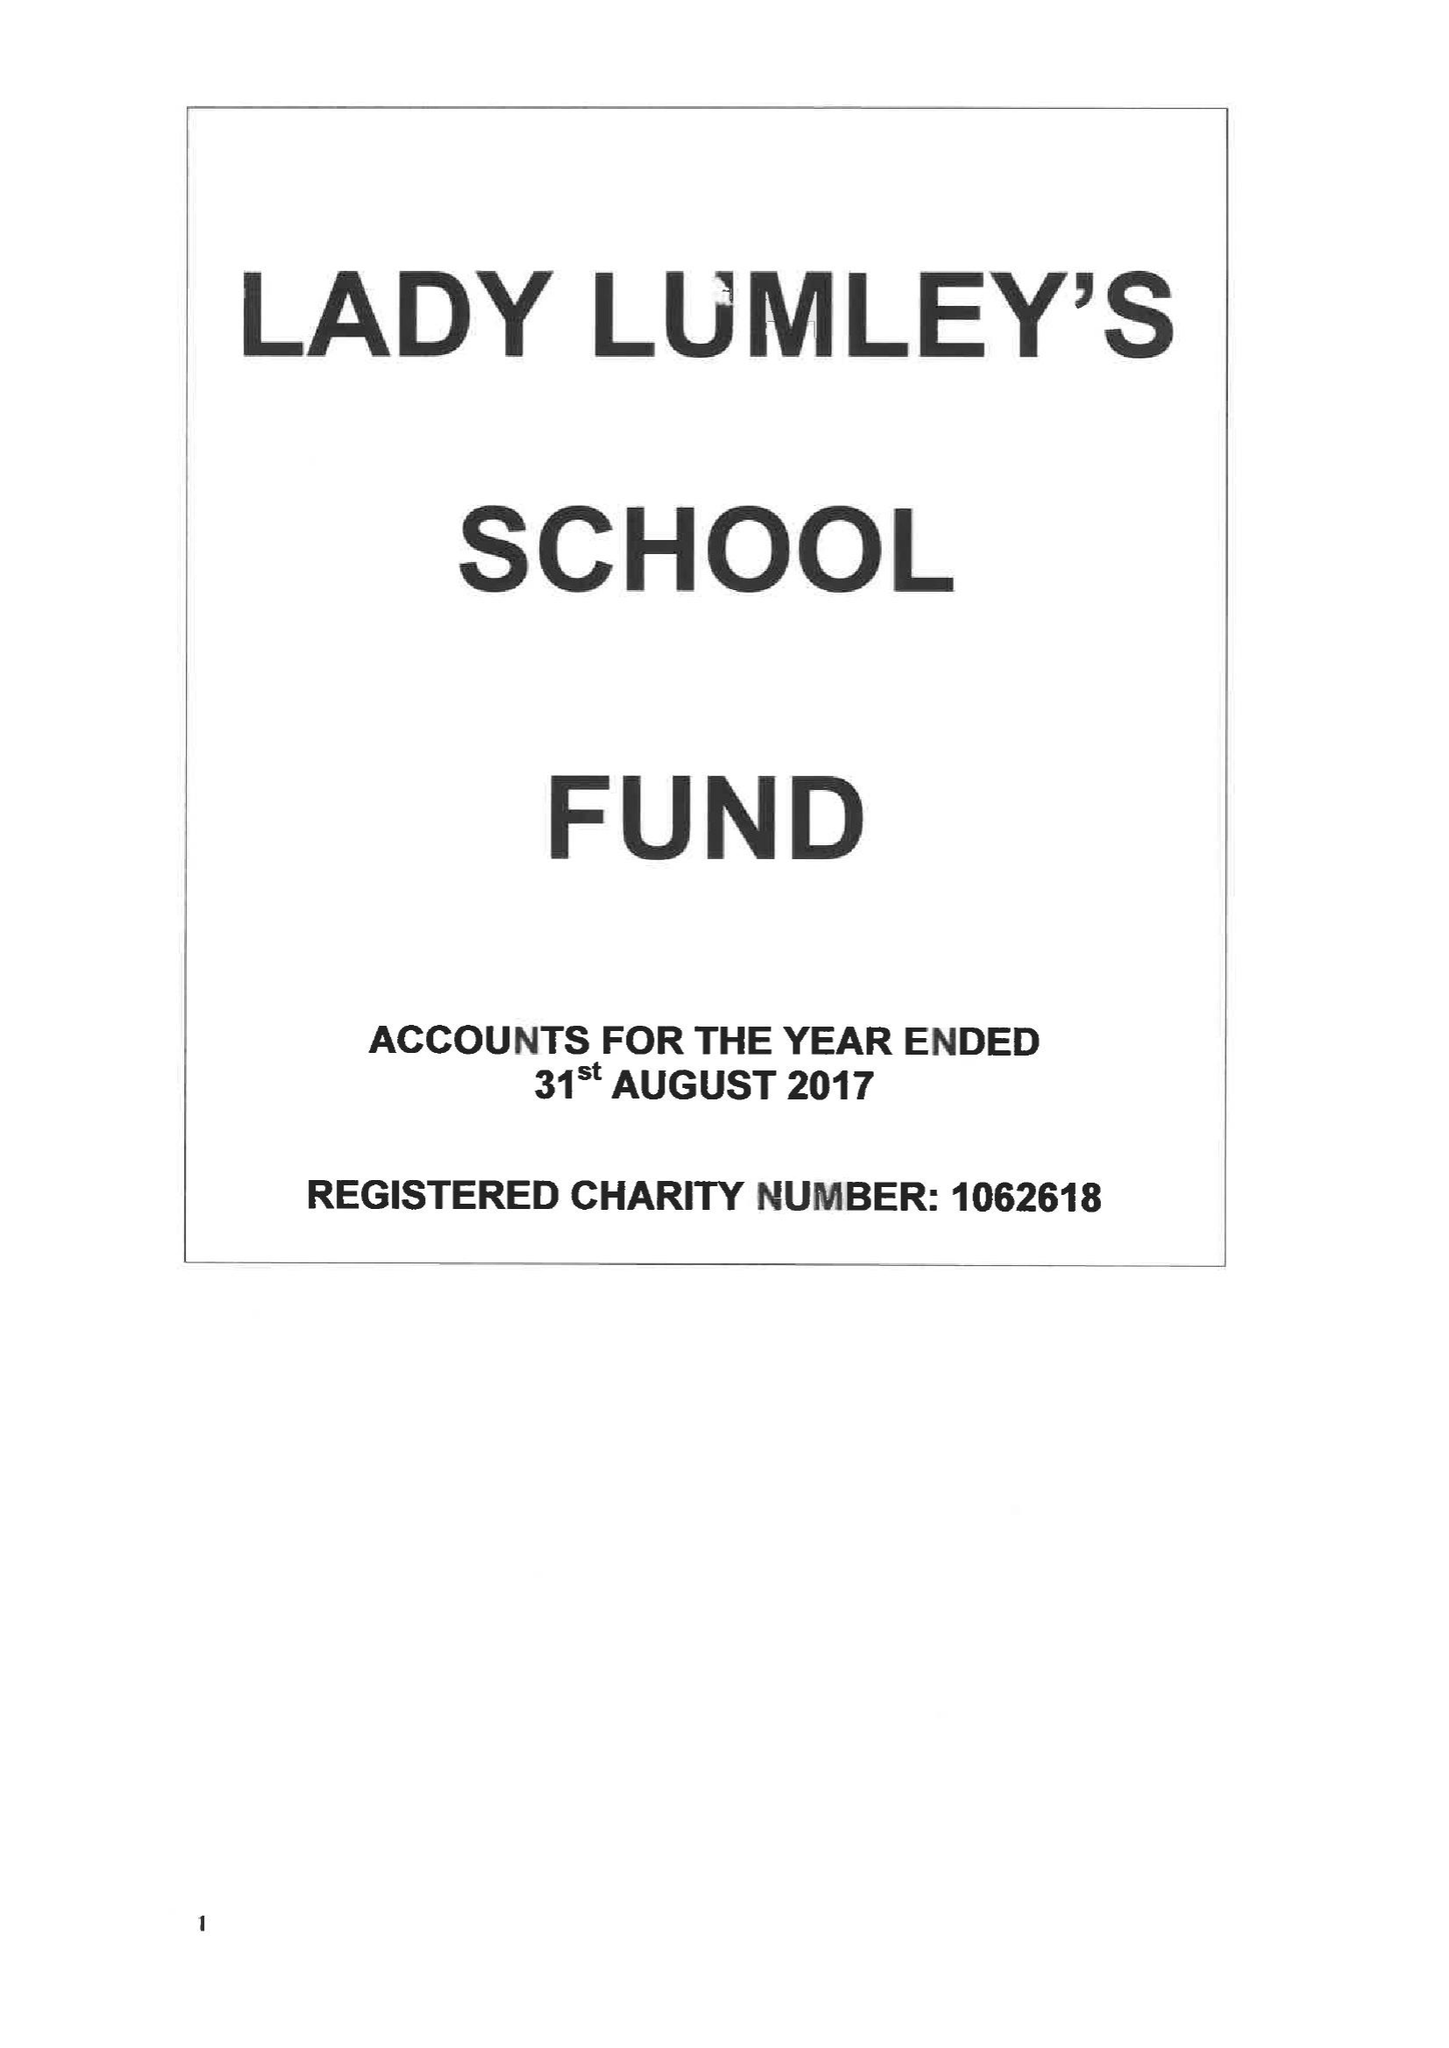What is the value for the report_date?
Answer the question using a single word or phrase. 2017-08-31 